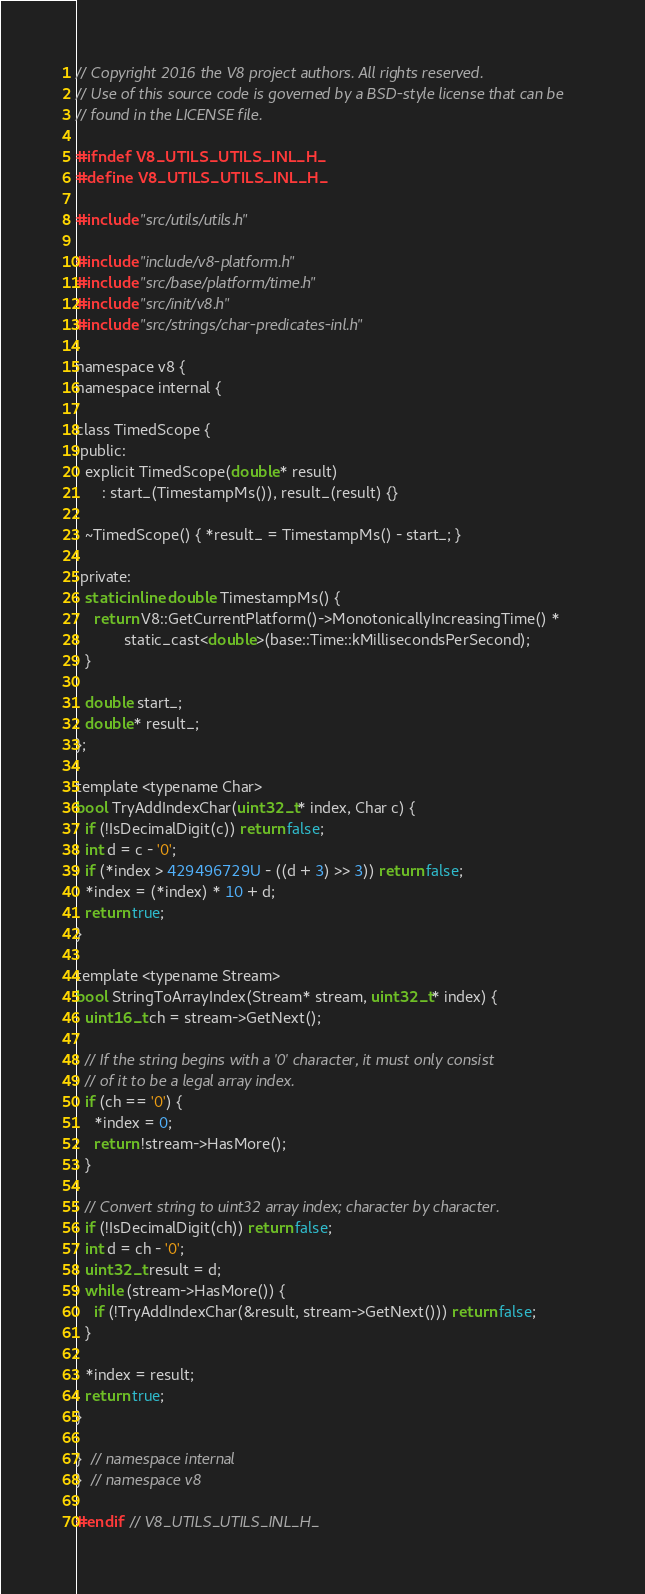<code> <loc_0><loc_0><loc_500><loc_500><_C_>// Copyright 2016 the V8 project authors. All rights reserved.
// Use of this source code is governed by a BSD-style license that can be
// found in the LICENSE file.

#ifndef V8_UTILS_UTILS_INL_H_
#define V8_UTILS_UTILS_INL_H_

#include "src/utils/utils.h"

#include "include/v8-platform.h"
#include "src/base/platform/time.h"
#include "src/init/v8.h"
#include "src/strings/char-predicates-inl.h"

namespace v8 {
namespace internal {

class TimedScope {
 public:
  explicit TimedScope(double* result)
      : start_(TimestampMs()), result_(result) {}

  ~TimedScope() { *result_ = TimestampMs() - start_; }

 private:
  static inline double TimestampMs() {
    return V8::GetCurrentPlatform()->MonotonicallyIncreasingTime() *
           static_cast<double>(base::Time::kMillisecondsPerSecond);
  }

  double start_;
  double* result_;
};

template <typename Char>
bool TryAddIndexChar(uint32_t* index, Char c) {
  if (!IsDecimalDigit(c)) return false;
  int d = c - '0';
  if (*index > 429496729U - ((d + 3) >> 3)) return false;
  *index = (*index) * 10 + d;
  return true;
}

template <typename Stream>
bool StringToArrayIndex(Stream* stream, uint32_t* index) {
  uint16_t ch = stream->GetNext();

  // If the string begins with a '0' character, it must only consist
  // of it to be a legal array index.
  if (ch == '0') {
    *index = 0;
    return !stream->HasMore();
  }

  // Convert string to uint32 array index; character by character.
  if (!IsDecimalDigit(ch)) return false;
  int d = ch - '0';
  uint32_t result = d;
  while (stream->HasMore()) {
    if (!TryAddIndexChar(&result, stream->GetNext())) return false;
  }

  *index = result;
  return true;
}

}  // namespace internal
}  // namespace v8

#endif  // V8_UTILS_UTILS_INL_H_
</code> 